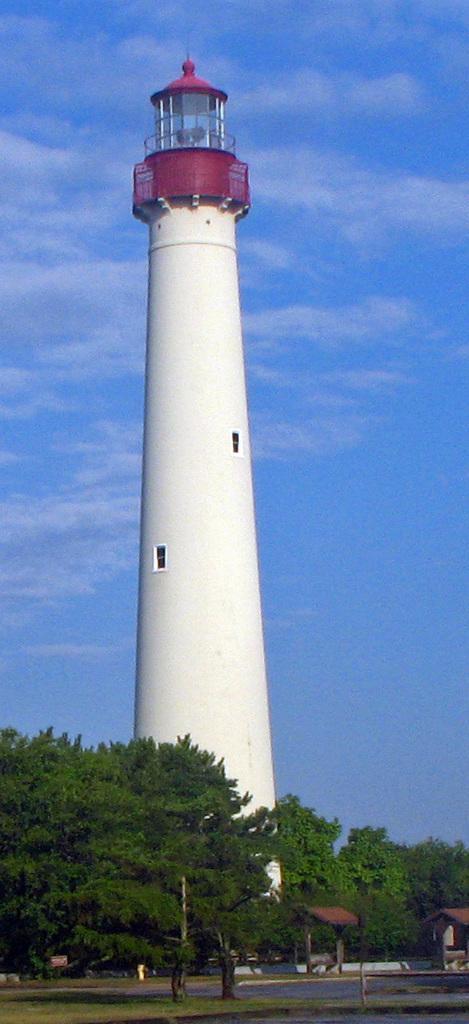Can you describe this image briefly? At the bottom I can see grass, road, trees and shed. In the background I can see a light tower and the sky. This image is taken may be during a day. 